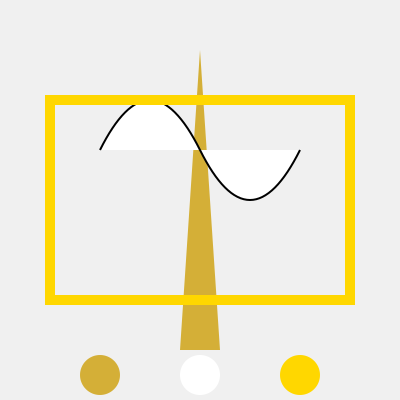Match the sneaker colorways represented by the circles at the bottom to the iconic Dubai landmarks shown above. Which colorway corresponds to the Burj Khalifa? To answer this question, we need to analyze the colors of the landmarks and match them to the sneaker colorways:

1. Burj Khalifa: This iconic skyscraper is represented by the tall, slender triangle in the center. It's colored in a gold-like shade (#d4af37).

2. Burj Al Arab: The sail-shaped hotel is represented by the curved white shape with a black outline.

3. Dubai Frame: This landmark is shown as a large rectangle outline in a bright gold color (#ffd700).

Looking at the sneaker colorways at the bottom:
- Left circle: Gold (#d4af37)
- Middle circle: White
- Right circle: Bright gold (#ffd700)

Comparing these to the landmarks, we can see that the Burj Khalifa's color matches the left circle, which is the gold (#d4af37) colorway.
Answer: Gold (#d4af37) 